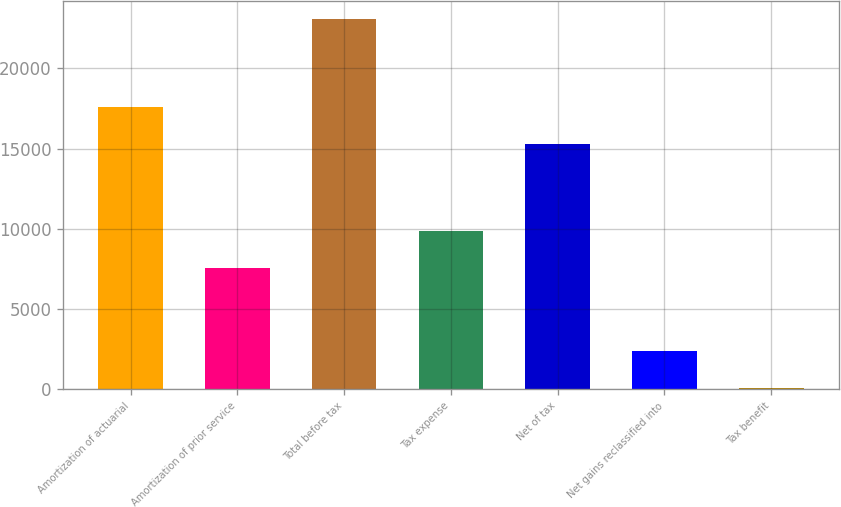<chart> <loc_0><loc_0><loc_500><loc_500><bar_chart><fcel>Amortization of actuarial<fcel>Amortization of prior service<fcel>Total before tax<fcel>Tax expense<fcel>Net of tax<fcel>Net gains reclassified into<fcel>Tax benefit<nl><fcel>17601<fcel>7541<fcel>23068<fcel>9842<fcel>15300<fcel>2359<fcel>58<nl></chart> 